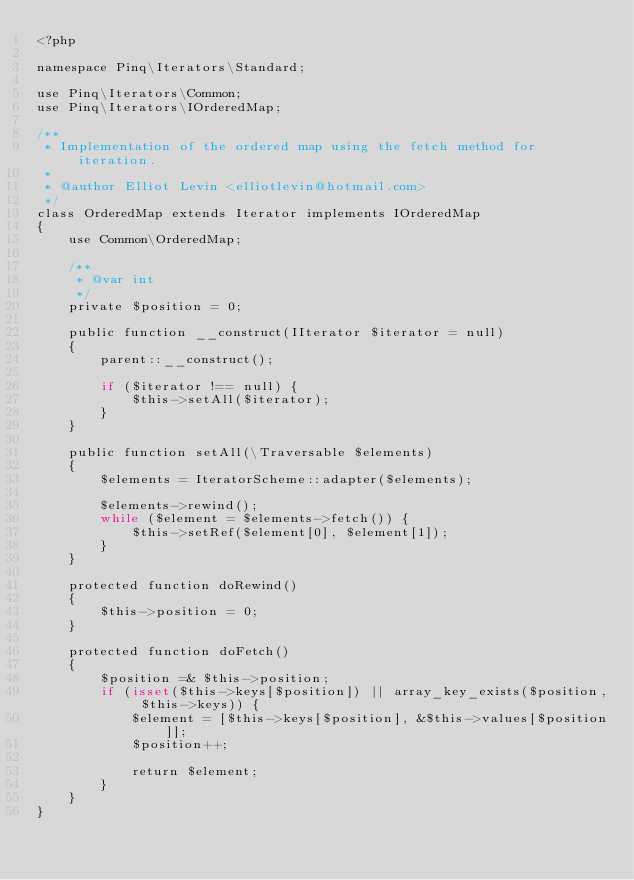<code> <loc_0><loc_0><loc_500><loc_500><_PHP_><?php

namespace Pinq\Iterators\Standard;

use Pinq\Iterators\Common;
use Pinq\Iterators\IOrderedMap;

/**
 * Implementation of the ordered map using the fetch method for iteration.
 *
 * @author Elliot Levin <elliotlevin@hotmail.com>
 */
class OrderedMap extends Iterator implements IOrderedMap
{
    use Common\OrderedMap;

    /**
     * @var int
     */
    private $position = 0;

    public function __construct(IIterator $iterator = null)
    {
        parent::__construct();

        if ($iterator !== null) {
            $this->setAll($iterator);
        }
    }

    public function setAll(\Traversable $elements)
    {
        $elements = IteratorScheme::adapter($elements);

        $elements->rewind();
        while ($element = $elements->fetch()) {
            $this->setRef($element[0], $element[1]);
        }
    }

    protected function doRewind()
    {
        $this->position = 0;
    }

    protected function doFetch()
    {
        $position =& $this->position;
        if (isset($this->keys[$position]) || array_key_exists($position, $this->keys)) {
            $element = [$this->keys[$position], &$this->values[$position]];
            $position++;

            return $element;
        }
    }
}
</code> 